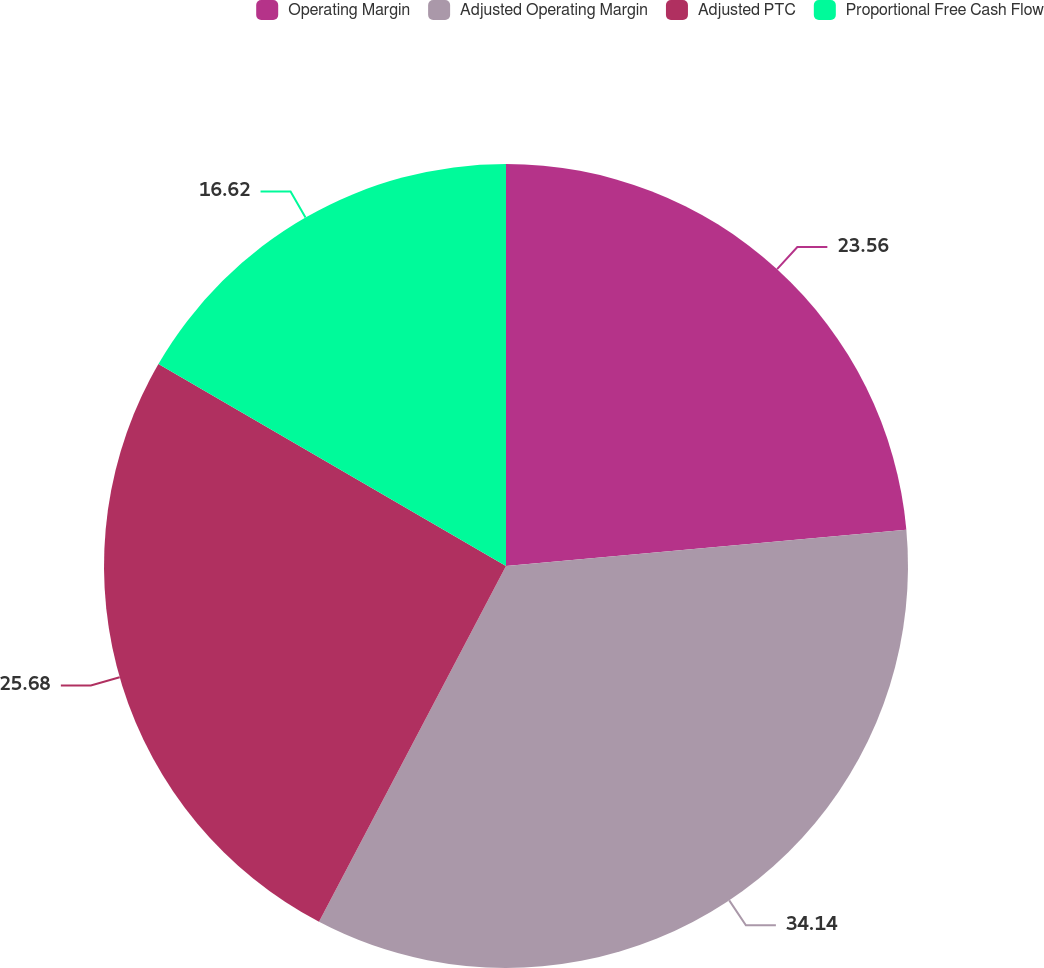<chart> <loc_0><loc_0><loc_500><loc_500><pie_chart><fcel>Operating Margin<fcel>Adjusted Operating Margin<fcel>Adjusted PTC<fcel>Proportional Free Cash Flow<nl><fcel>23.56%<fcel>34.14%<fcel>25.68%<fcel>16.62%<nl></chart> 